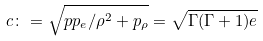<formula> <loc_0><loc_0><loc_500><loc_500>c \colon = \sqrt { p p _ { e } / \rho ^ { 2 } + p _ { \rho } } = \sqrt { \Gamma ( \Gamma + 1 ) e }</formula> 